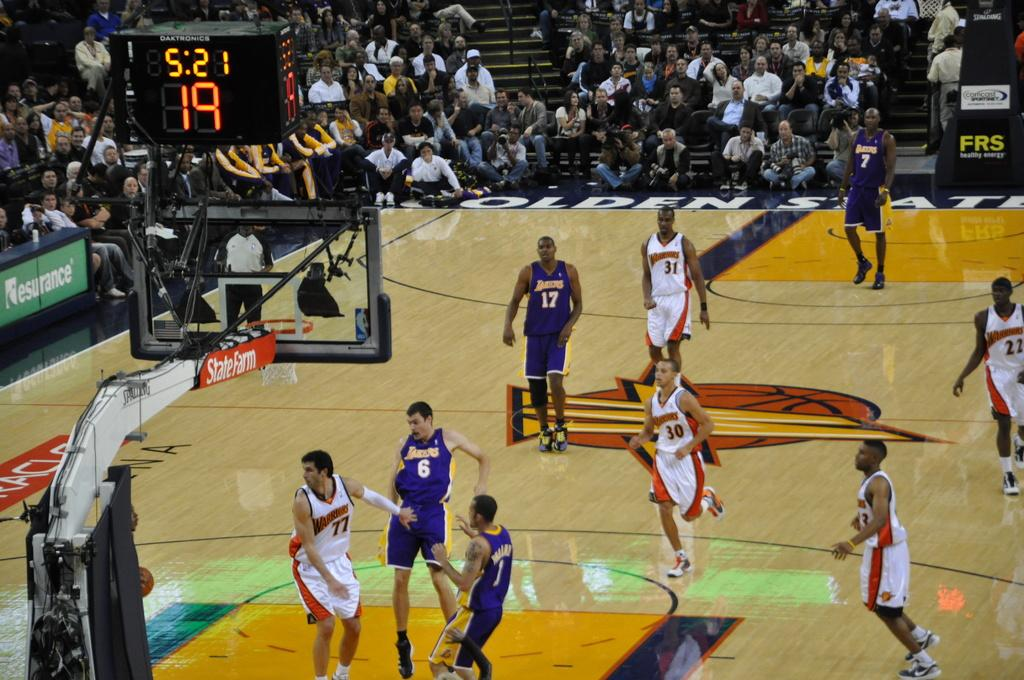<image>
Write a terse but informative summary of the picture. A State Farm advertisement hangs to the side of a basketball game. 